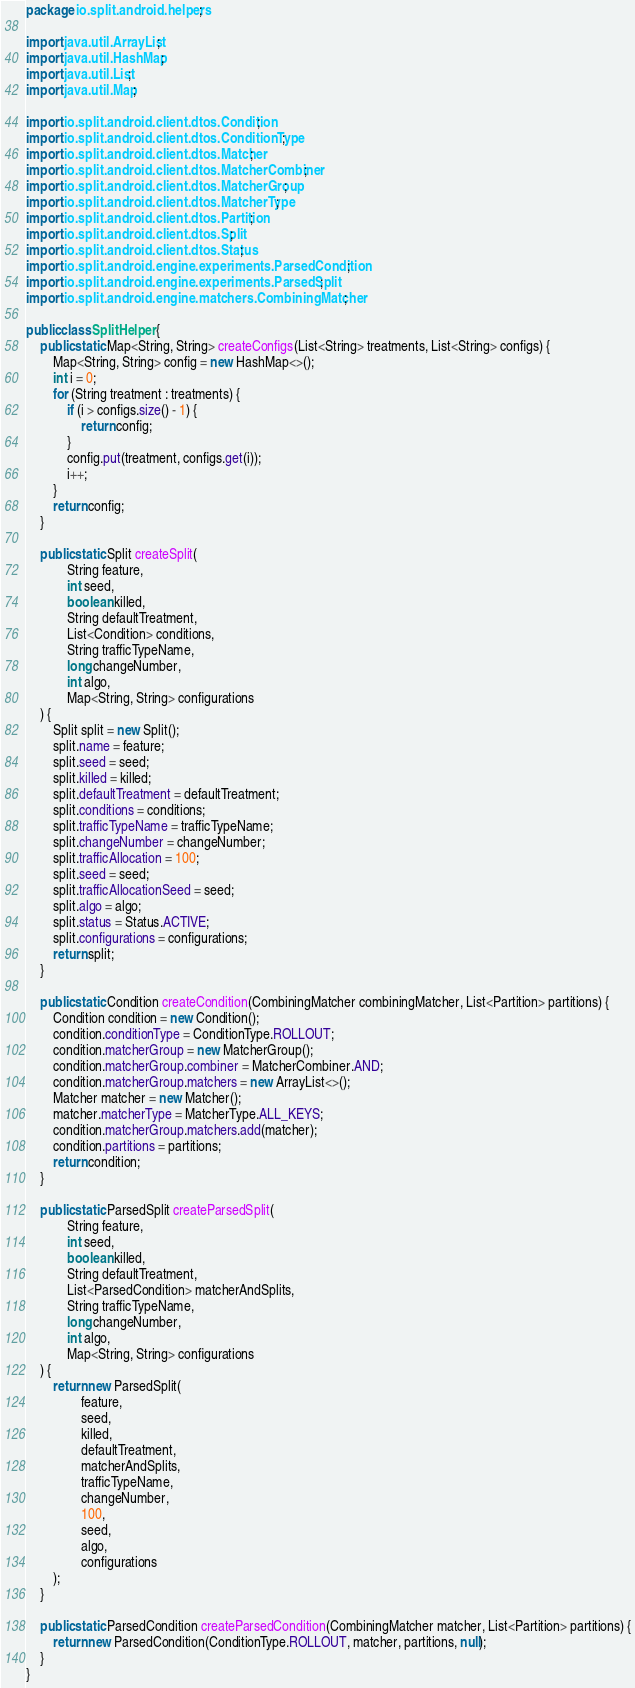Convert code to text. <code><loc_0><loc_0><loc_500><loc_500><_Java_>package io.split.android.helpers;

import java.util.ArrayList;
import java.util.HashMap;
import java.util.List;
import java.util.Map;

import io.split.android.client.dtos.Condition;
import io.split.android.client.dtos.ConditionType;
import io.split.android.client.dtos.Matcher;
import io.split.android.client.dtos.MatcherCombiner;
import io.split.android.client.dtos.MatcherGroup;
import io.split.android.client.dtos.MatcherType;
import io.split.android.client.dtos.Partition;
import io.split.android.client.dtos.Split;
import io.split.android.client.dtos.Status;
import io.split.android.engine.experiments.ParsedCondition;
import io.split.android.engine.experiments.ParsedSplit;
import io.split.android.engine.matchers.CombiningMatcher;

public class SplitHelper {
    public static Map<String, String> createConfigs(List<String> treatments, List<String> configs) {
        Map<String, String> config = new HashMap<>();
        int i = 0;
        for (String treatment : treatments) {
            if (i > configs.size() - 1) {
                return config;
            }
            config.put(treatment, configs.get(i));
            i++;
        }
        return config;
    }

    public static Split createSplit(
            String feature,
            int seed,
            boolean killed,
            String defaultTreatment,
            List<Condition> conditions,
            String trafficTypeName,
            long changeNumber,
            int algo,
            Map<String, String> configurations
    ) {
        Split split = new Split();
        split.name = feature;
        split.seed = seed;
        split.killed = killed;
        split.defaultTreatment = defaultTreatment;
        split.conditions = conditions;
        split.trafficTypeName = trafficTypeName;
        split.changeNumber = changeNumber;
        split.trafficAllocation = 100;
        split.seed = seed;
        split.trafficAllocationSeed = seed;
        split.algo = algo;
        split.status = Status.ACTIVE;
        split.configurations = configurations;
        return split;
    }

    public static Condition createCondition(CombiningMatcher combiningMatcher, List<Partition> partitions) {
        Condition condition = new Condition();
        condition.conditionType = ConditionType.ROLLOUT;
        condition.matcherGroup = new MatcherGroup();
        condition.matcherGroup.combiner = MatcherCombiner.AND;
        condition.matcherGroup.matchers = new ArrayList<>();
        Matcher matcher = new Matcher();
        matcher.matcherType = MatcherType.ALL_KEYS;
        condition.matcherGroup.matchers.add(matcher);
        condition.partitions = partitions;
        return condition;
    }

    public static ParsedSplit createParsedSplit(
            String feature,
            int seed,
            boolean killed,
            String defaultTreatment,
            List<ParsedCondition> matcherAndSplits,
            String trafficTypeName,
            long changeNumber,
            int algo,
            Map<String, String> configurations
    ) {
        return new ParsedSplit(
                feature,
                seed,
                killed,
                defaultTreatment,
                matcherAndSplits,
                trafficTypeName,
                changeNumber,
                100,
                seed,
                algo,
                configurations
        );
    }

    public static ParsedCondition createParsedCondition(CombiningMatcher matcher, List<Partition> partitions) {
        return new ParsedCondition(ConditionType.ROLLOUT, matcher, partitions, null);
    }
}
</code> 